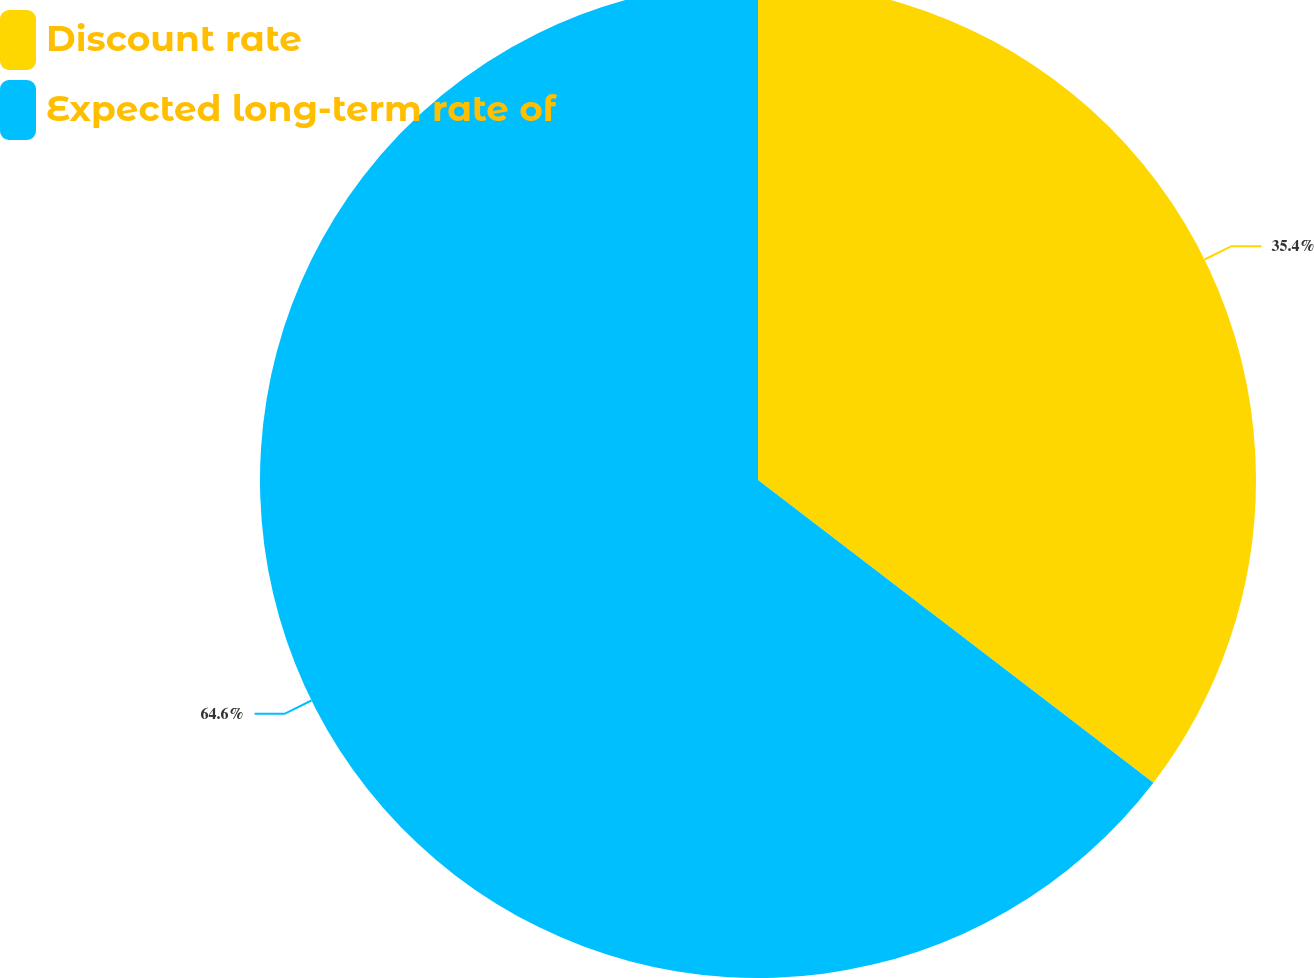Convert chart to OTSL. <chart><loc_0><loc_0><loc_500><loc_500><pie_chart><fcel>Discount rate<fcel>Expected long-term rate of<nl><fcel>35.4%<fcel>64.6%<nl></chart> 